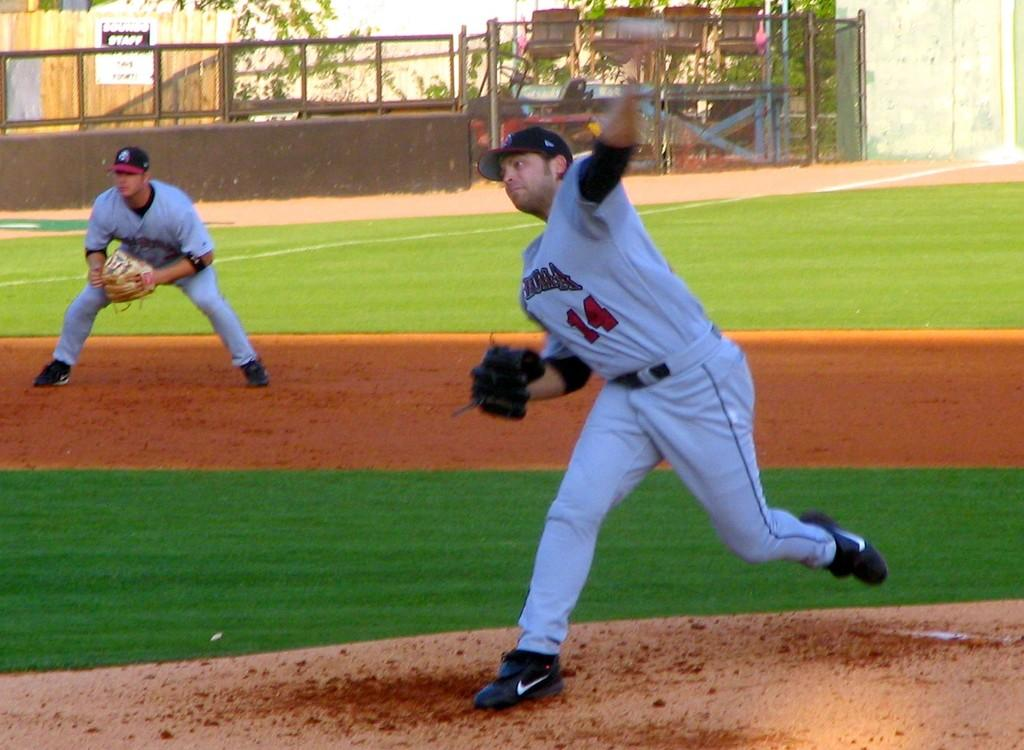<image>
Share a concise interpretation of the image provided. Player number 14 in a gray uniform pitches a ball while the shortstop crouches on the baseline. 